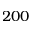<formula> <loc_0><loc_0><loc_500><loc_500>2 0 0</formula> 